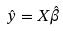<formula> <loc_0><loc_0><loc_500><loc_500>\hat { y } = X \hat { \beta }</formula> 